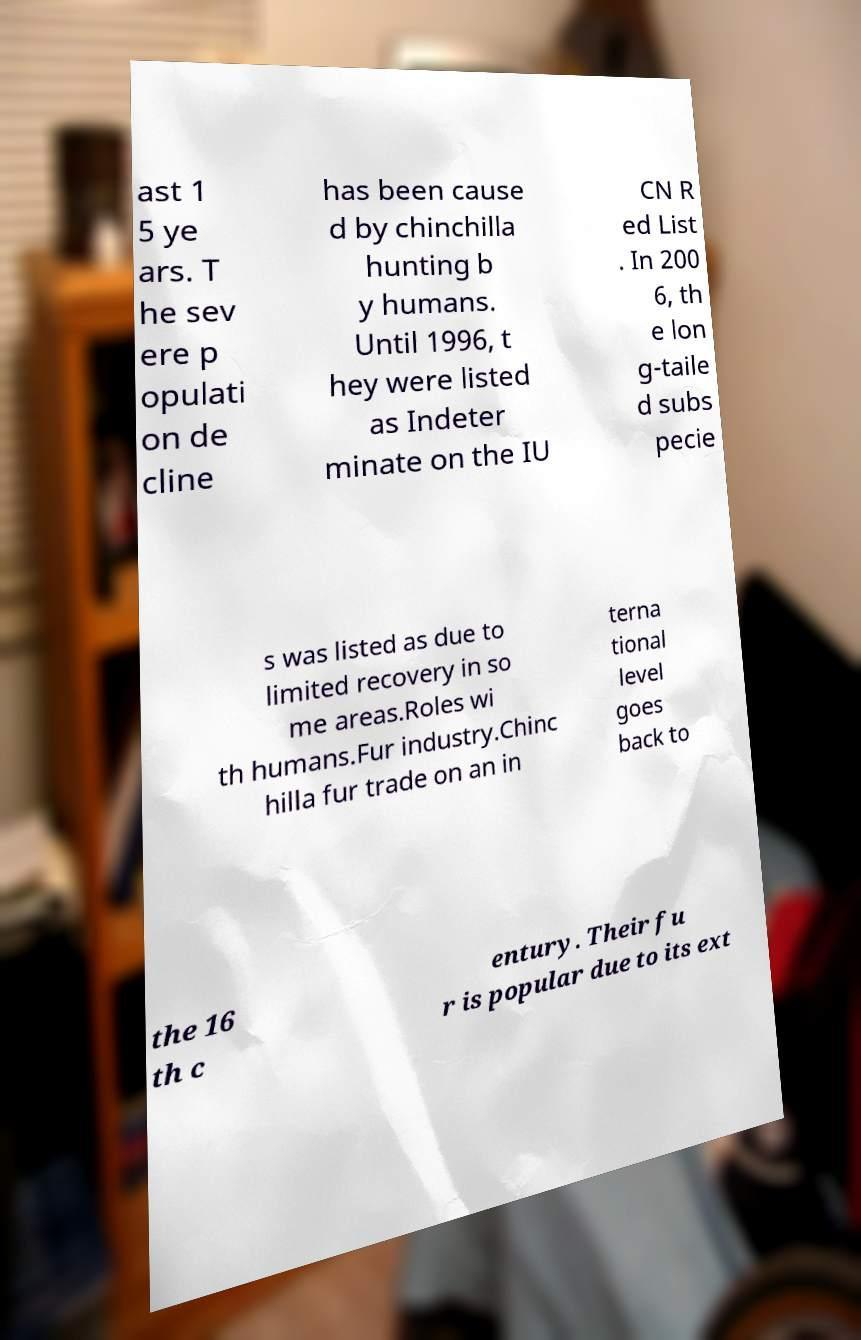Could you extract and type out the text from this image? ast 1 5 ye ars. T he sev ere p opulati on de cline has been cause d by chinchilla hunting b y humans. Until 1996, t hey were listed as Indeter minate on the IU CN R ed List . In 200 6, th e lon g-taile d subs pecie s was listed as due to limited recovery in so me areas.Roles wi th humans.Fur industry.Chinc hilla fur trade on an in terna tional level goes back to the 16 th c entury. Their fu r is popular due to its ext 